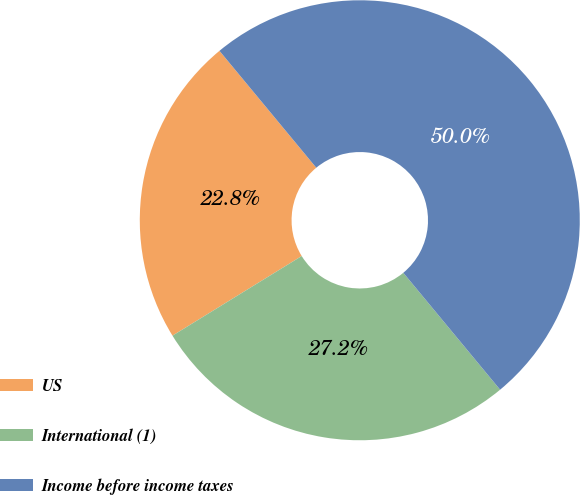Convert chart to OTSL. <chart><loc_0><loc_0><loc_500><loc_500><pie_chart><fcel>US<fcel>International (1)<fcel>Income before income taxes<nl><fcel>22.78%<fcel>27.22%<fcel>50.0%<nl></chart> 